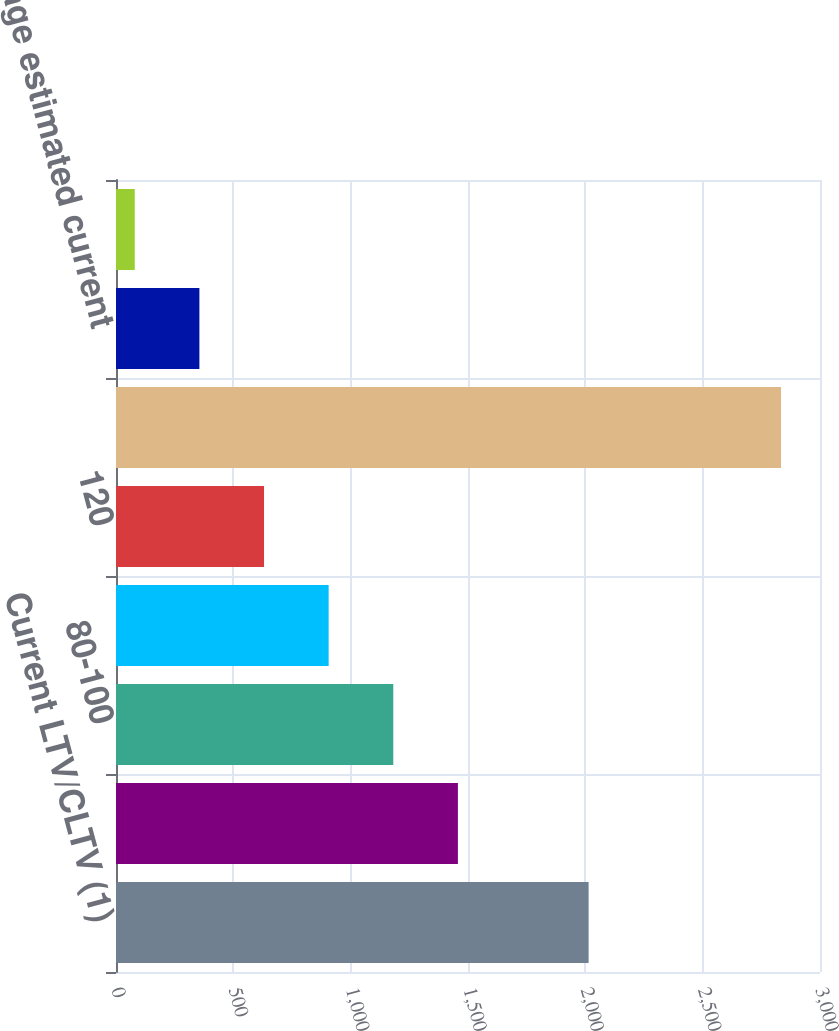<chart> <loc_0><loc_0><loc_500><loc_500><bar_chart><fcel>Current LTV/CLTV (1)<fcel>=80<fcel>80-100<fcel>100-120<fcel>120<fcel>Total mortgage loans<fcel>Average estimated current<fcel>Average LTV/CLTV at loan<nl><fcel>2014<fcel>1457<fcel>1181.6<fcel>906.2<fcel>630.8<fcel>2834<fcel>355.4<fcel>80<nl></chart> 